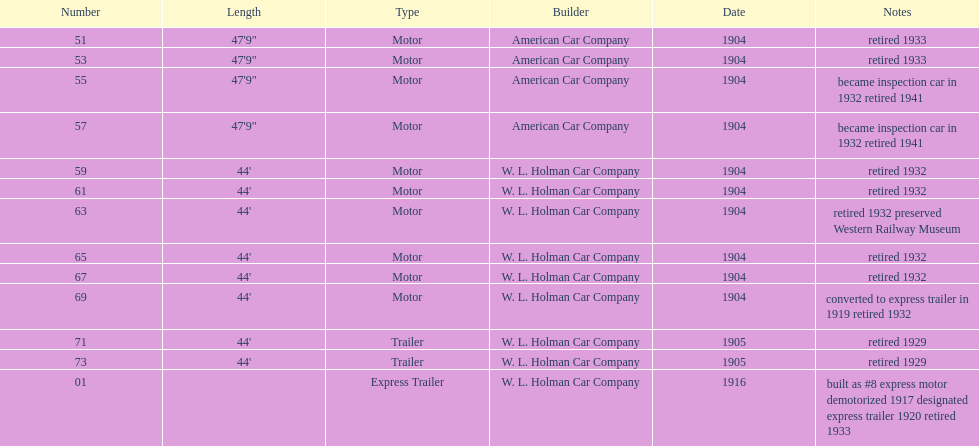What was the total number of cars listed? 13. 